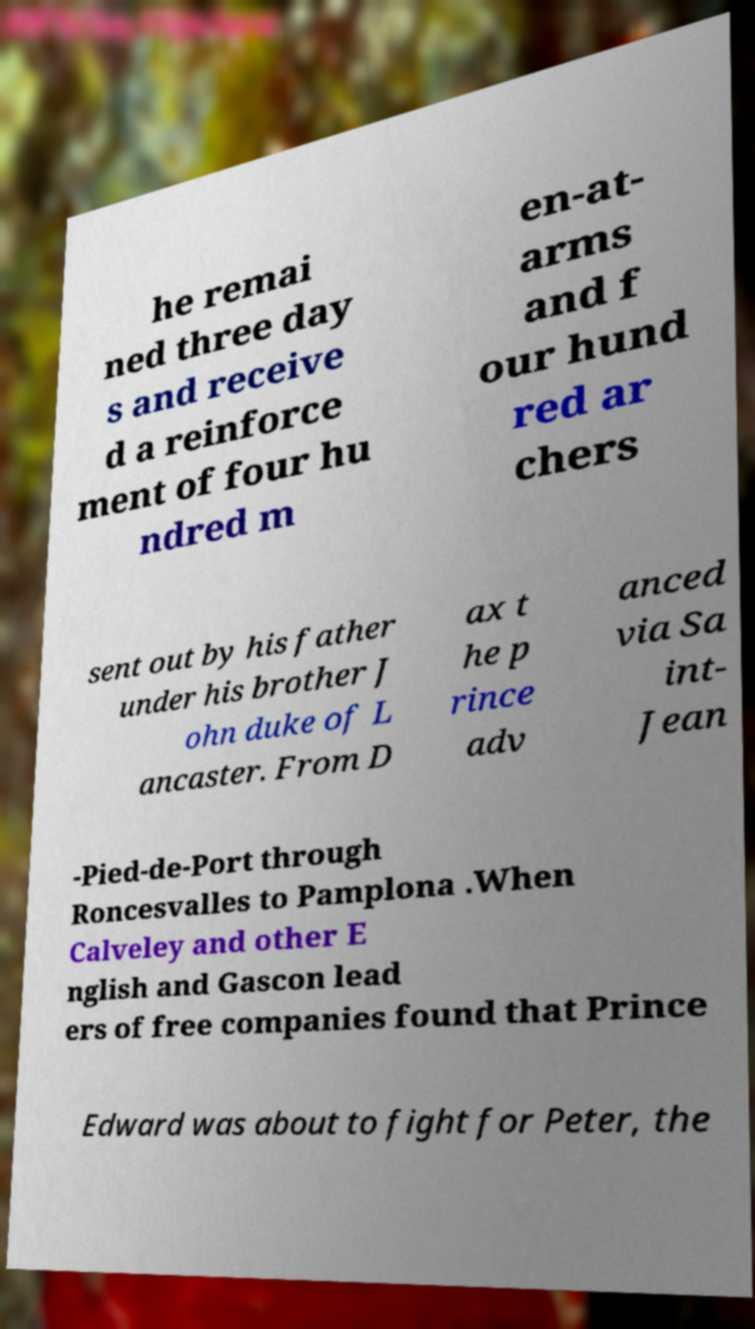For documentation purposes, I need the text within this image transcribed. Could you provide that? he remai ned three day s and receive d a reinforce ment of four hu ndred m en-at- arms and f our hund red ar chers sent out by his father under his brother J ohn duke of L ancaster. From D ax t he p rince adv anced via Sa int- Jean -Pied-de-Port through Roncesvalles to Pamplona .When Calveley and other E nglish and Gascon lead ers of free companies found that Prince Edward was about to fight for Peter, the 